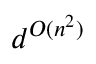Convert formula to latex. <formula><loc_0><loc_0><loc_500><loc_500>d ^ { O ( n ^ { 2 } ) }</formula> 